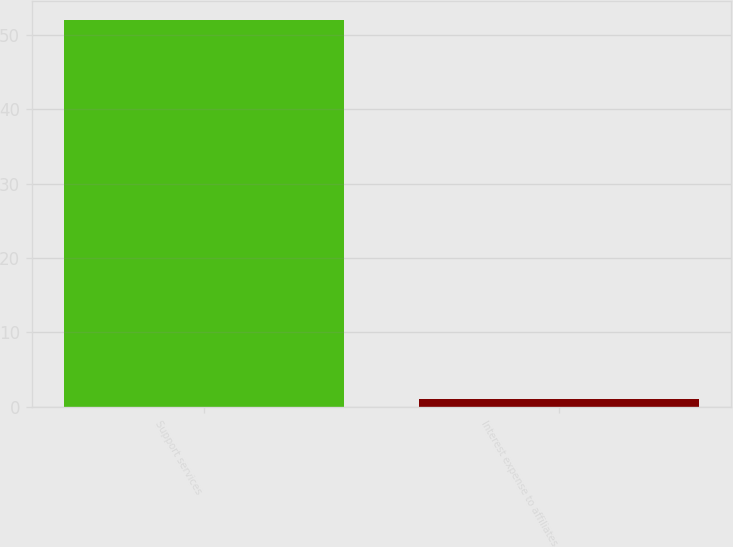Convert chart. <chart><loc_0><loc_0><loc_500><loc_500><bar_chart><fcel>Support services<fcel>Interest expense to affiliates<nl><fcel>52<fcel>1<nl></chart> 